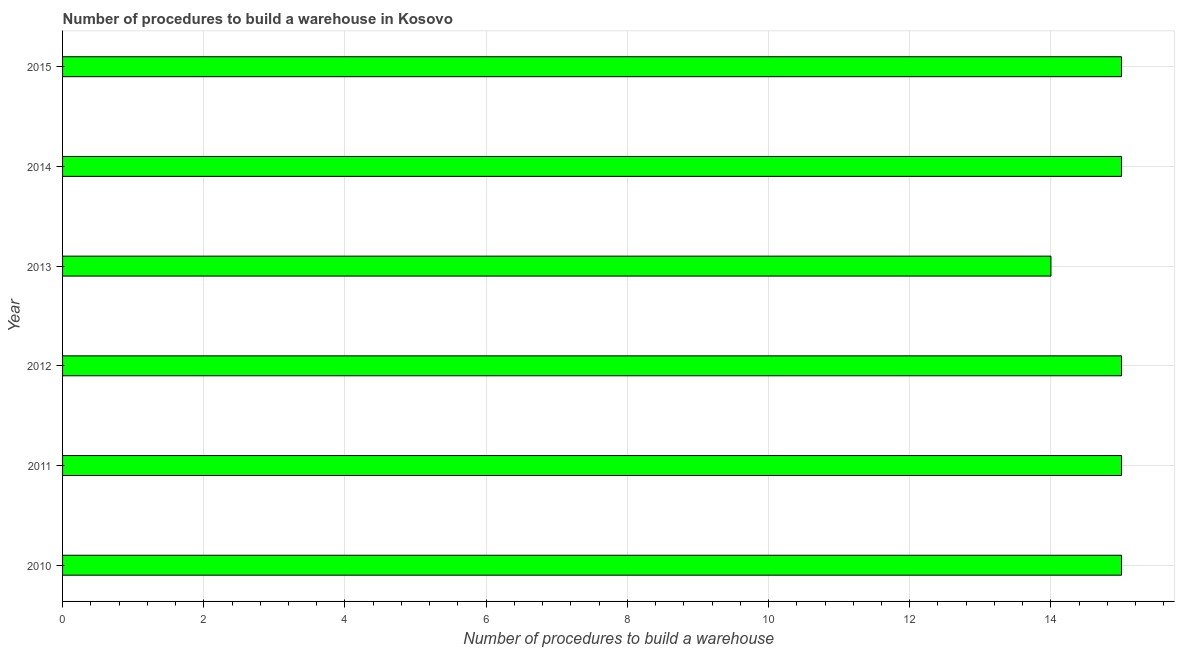Does the graph contain any zero values?
Make the answer very short. No. Does the graph contain grids?
Provide a short and direct response. Yes. What is the title of the graph?
Ensure brevity in your answer.  Number of procedures to build a warehouse in Kosovo. What is the label or title of the X-axis?
Offer a very short reply. Number of procedures to build a warehouse. What is the number of procedures to build a warehouse in 2012?
Provide a short and direct response. 15. In which year was the number of procedures to build a warehouse maximum?
Provide a short and direct response. 2010. In which year was the number of procedures to build a warehouse minimum?
Offer a very short reply. 2013. What is the sum of the number of procedures to build a warehouse?
Offer a very short reply. 89. What is the median number of procedures to build a warehouse?
Offer a terse response. 15. In how many years, is the number of procedures to build a warehouse greater than 0.8 ?
Your response must be concise. 6. Do a majority of the years between 2014 and 2012 (inclusive) have number of procedures to build a warehouse greater than 11.6 ?
Keep it short and to the point. Yes. What is the ratio of the number of procedures to build a warehouse in 2010 to that in 2015?
Keep it short and to the point. 1. Is the number of procedures to build a warehouse in 2012 less than that in 2014?
Ensure brevity in your answer.  No. What is the difference between the highest and the second highest number of procedures to build a warehouse?
Your answer should be very brief. 0. What is the difference between the highest and the lowest number of procedures to build a warehouse?
Provide a succinct answer. 1. In how many years, is the number of procedures to build a warehouse greater than the average number of procedures to build a warehouse taken over all years?
Your response must be concise. 5. How many bars are there?
Make the answer very short. 6. What is the difference between two consecutive major ticks on the X-axis?
Your answer should be compact. 2. What is the Number of procedures to build a warehouse of 2010?
Provide a short and direct response. 15. What is the Number of procedures to build a warehouse in 2011?
Make the answer very short. 15. What is the Number of procedures to build a warehouse of 2012?
Your response must be concise. 15. What is the Number of procedures to build a warehouse of 2013?
Provide a short and direct response. 14. What is the Number of procedures to build a warehouse in 2014?
Give a very brief answer. 15. What is the Number of procedures to build a warehouse of 2015?
Offer a terse response. 15. What is the difference between the Number of procedures to build a warehouse in 2010 and 2014?
Your answer should be compact. 0. What is the difference between the Number of procedures to build a warehouse in 2010 and 2015?
Keep it short and to the point. 0. What is the difference between the Number of procedures to build a warehouse in 2011 and 2013?
Offer a terse response. 1. What is the difference between the Number of procedures to build a warehouse in 2011 and 2015?
Offer a very short reply. 0. What is the difference between the Number of procedures to build a warehouse in 2012 and 2013?
Provide a short and direct response. 1. What is the difference between the Number of procedures to build a warehouse in 2012 and 2015?
Make the answer very short. 0. What is the difference between the Number of procedures to build a warehouse in 2014 and 2015?
Ensure brevity in your answer.  0. What is the ratio of the Number of procedures to build a warehouse in 2010 to that in 2012?
Provide a short and direct response. 1. What is the ratio of the Number of procedures to build a warehouse in 2010 to that in 2013?
Your answer should be compact. 1.07. What is the ratio of the Number of procedures to build a warehouse in 2010 to that in 2014?
Keep it short and to the point. 1. What is the ratio of the Number of procedures to build a warehouse in 2011 to that in 2013?
Make the answer very short. 1.07. What is the ratio of the Number of procedures to build a warehouse in 2012 to that in 2013?
Provide a short and direct response. 1.07. What is the ratio of the Number of procedures to build a warehouse in 2013 to that in 2014?
Ensure brevity in your answer.  0.93. What is the ratio of the Number of procedures to build a warehouse in 2013 to that in 2015?
Ensure brevity in your answer.  0.93. 